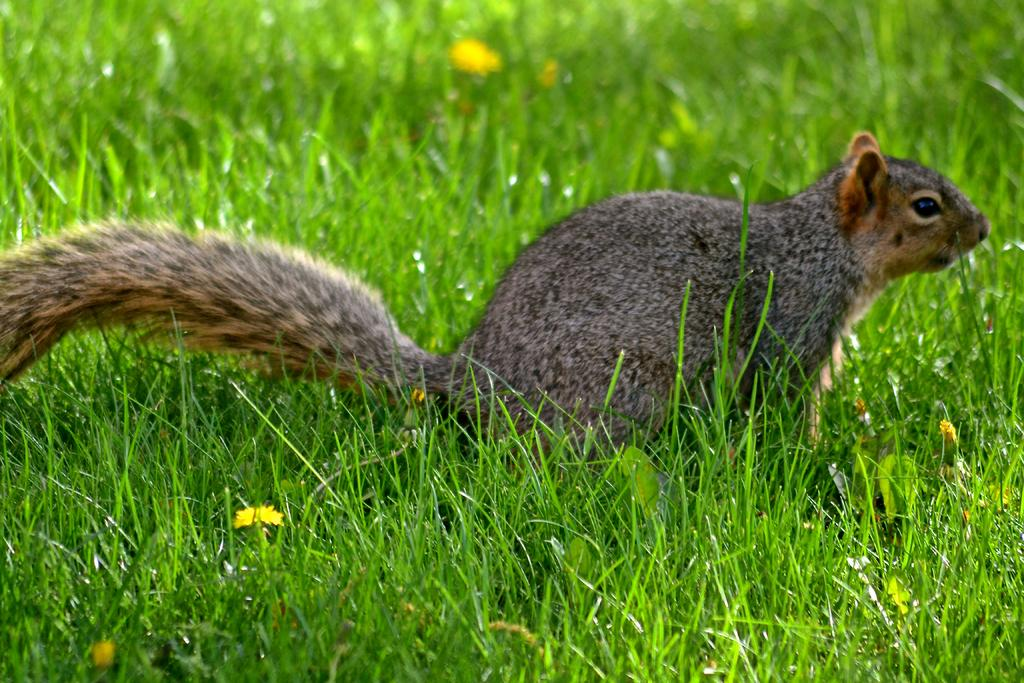What type of creature is in the image? There is an animal in the image. Where is the animal located? The animal is on the grass. What other natural elements can be seen in the image? There are flowers in the image. How many eggs are being used to create the art in the image? There is no art or eggs present in the image; it features an animal on the grass with flowers. 